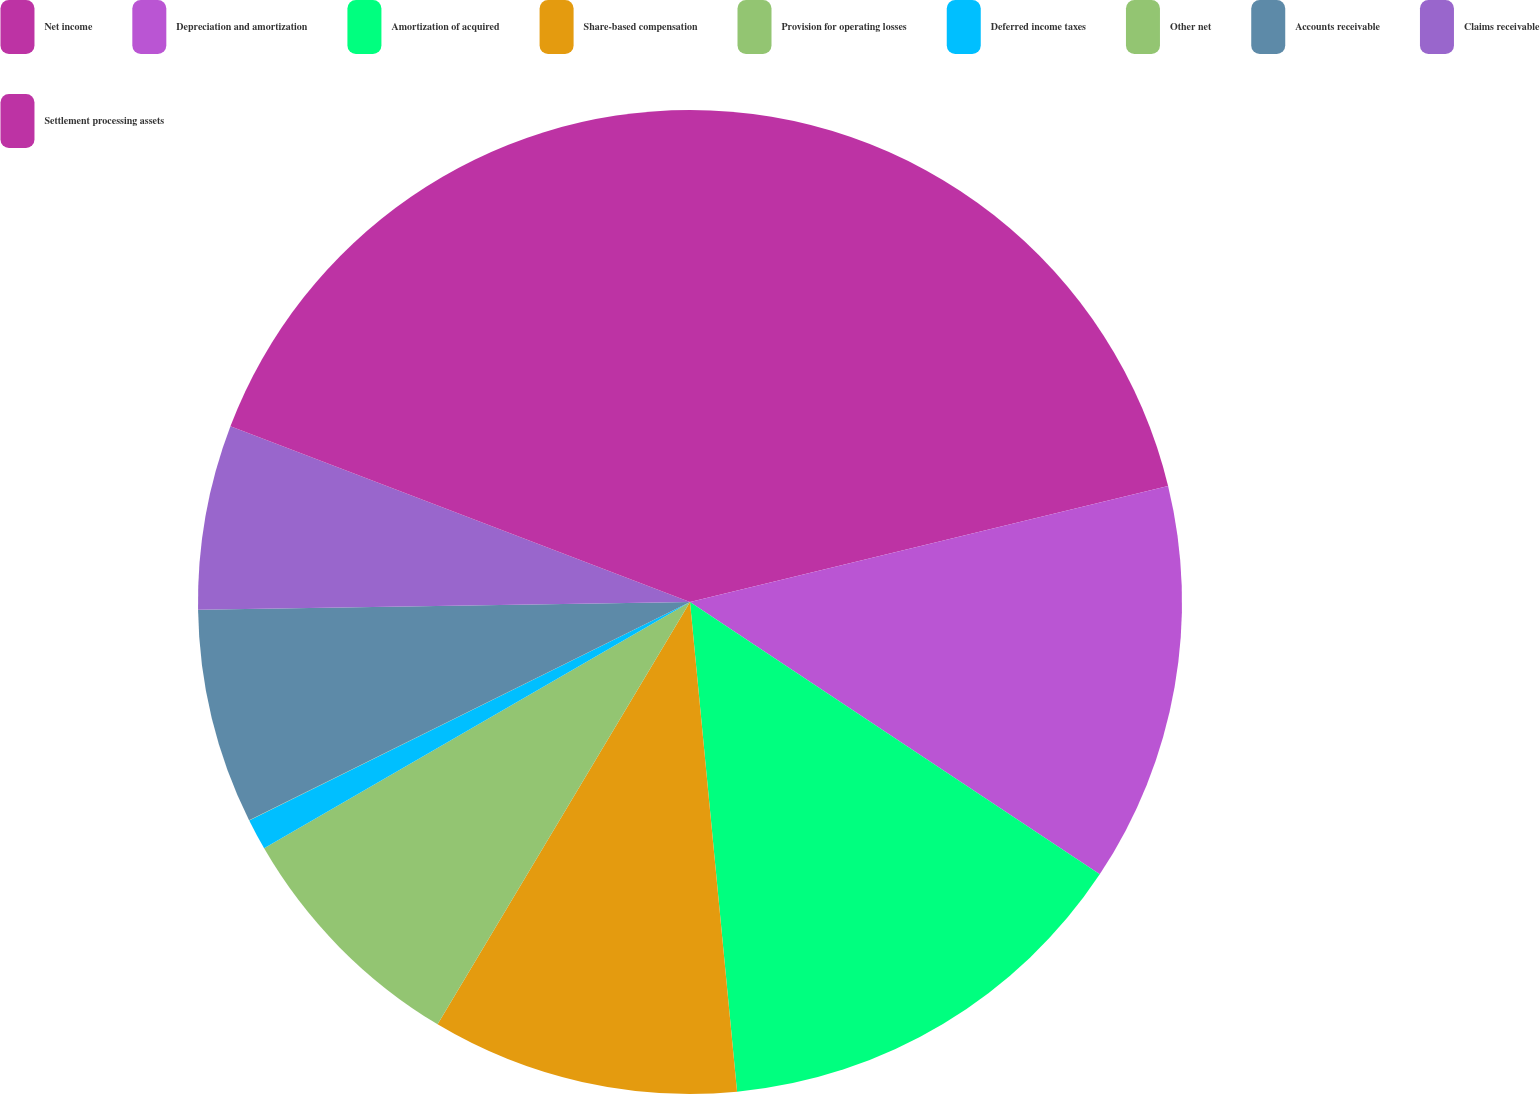<chart> <loc_0><loc_0><loc_500><loc_500><pie_chart><fcel>Net income<fcel>Depreciation and amortization<fcel>Amortization of acquired<fcel>Share-based compensation<fcel>Provision for operating losses<fcel>Deferred income taxes<fcel>Other net<fcel>Accounts receivable<fcel>Claims receivable<fcel>Settlement processing assets<nl><fcel>21.21%<fcel>13.13%<fcel>14.14%<fcel>10.1%<fcel>8.08%<fcel>1.02%<fcel>0.01%<fcel>7.07%<fcel>6.06%<fcel>19.19%<nl></chart> 